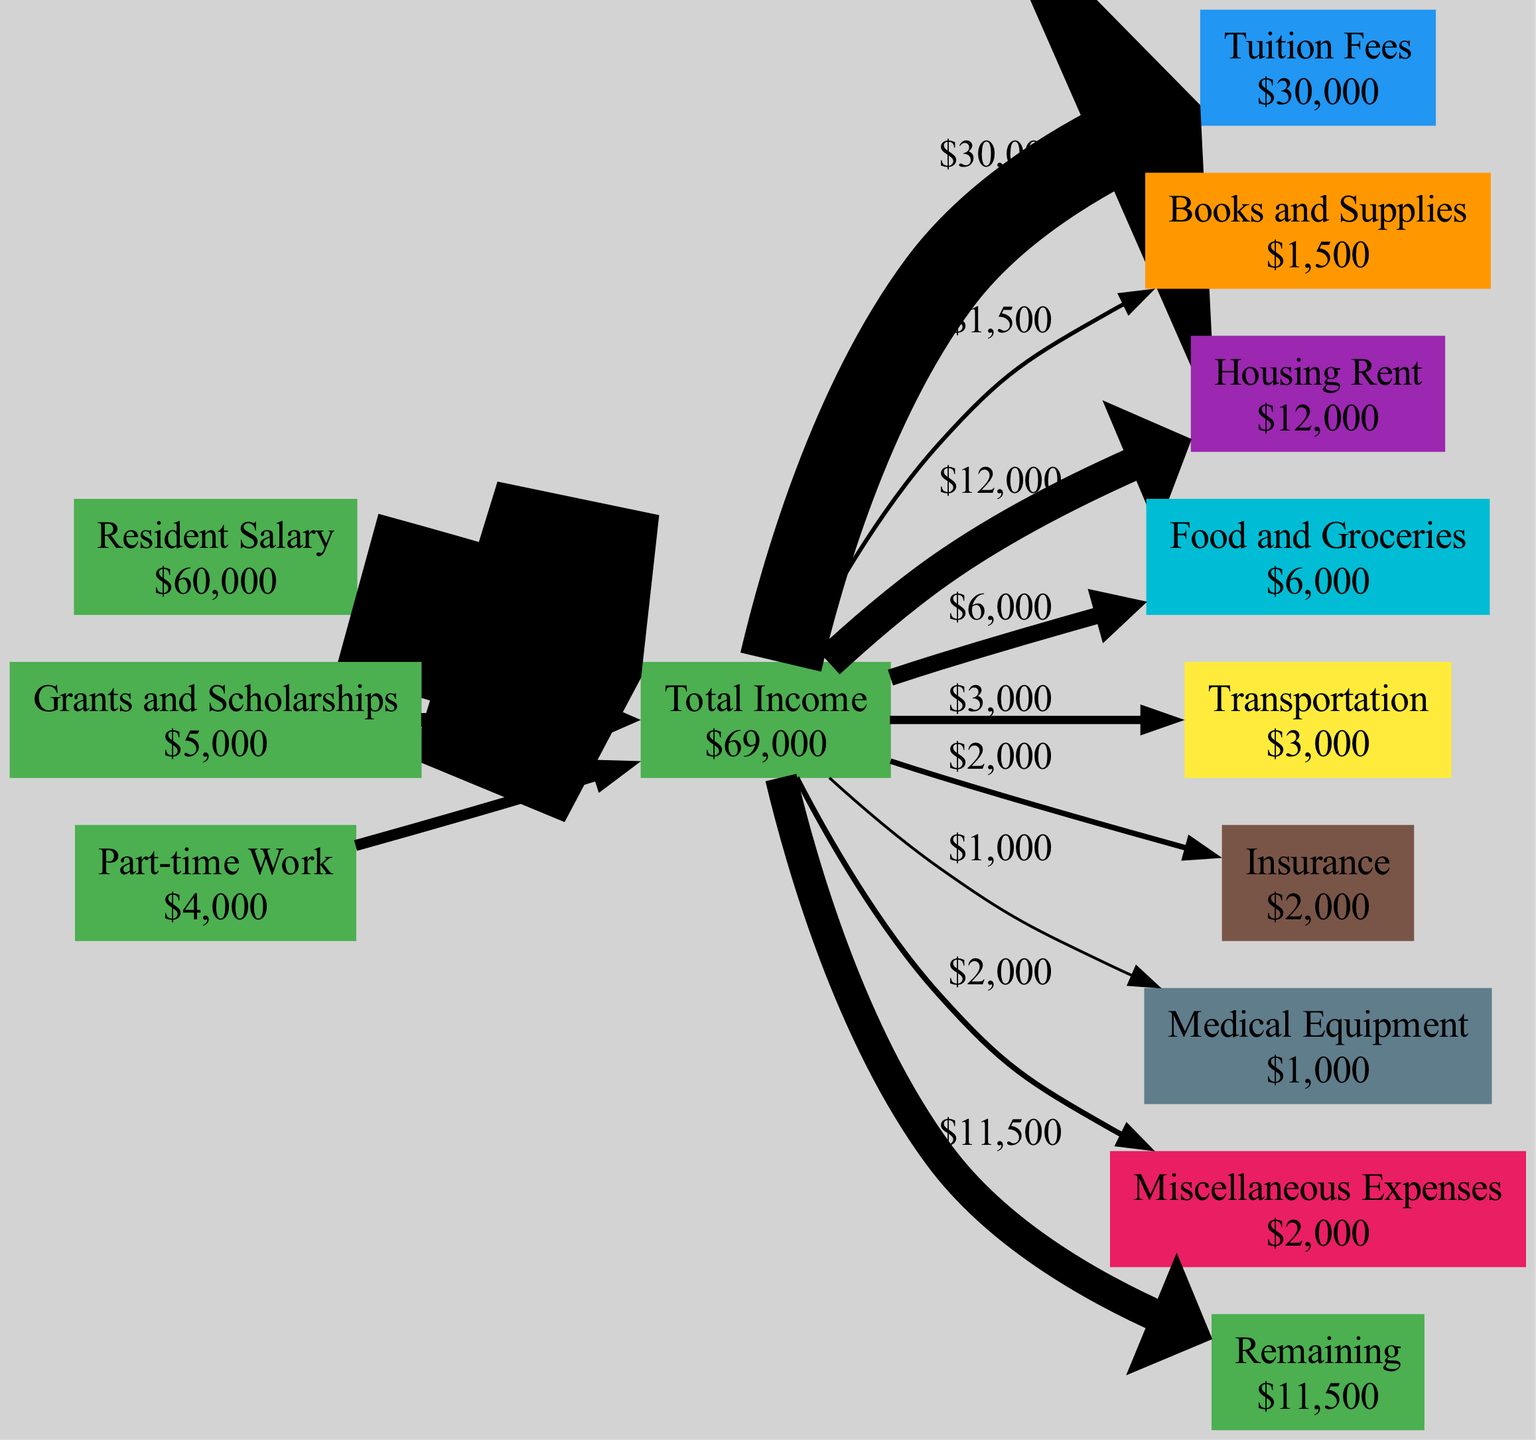What is the total amount of tuition fees? From the expenses section of the diagram, the node for Tuition Fees shows an amount of $30,000.
Answer: $30,000 What is the total income of the resident? The Total Income node aggregates all income amounts: Resident Salary ($60,000), Grants and Scholarships ($5,000), and Part-time Work ($4,000). Adding these gives $60,000 + $5,000 + $4,000 = $69,000.
Answer: $69,000 Which expense is the largest? By examining each expense amount listed in the diagram, Tuition Fees shows an amount of $30,000, which is greater than any other expense.
Answer: Tuition Fees How much is spent on food and groceries? The node for Food and Groceries explicitly lists an expense amount of $6,000 in the diagram.
Answer: $6,000 What is the remaining balance after all expenses? The diagram shows a remaining amount calculated by subtracting total expenses ($60,000) from total income ($69,000). The difference is $69,000 - $60,000 = $9,000.
Answer: $9,000 How many different types of expenses are represented? The diagram indicates eight expense nodes: Tuition Fees, Books and Supplies, Housing Rent, Food and Groceries, Transportation, Insurance, Medical Equipment, and Miscellaneous Expenses, totaling eight distinct types.
Answer: 8 What is the percentage of expenses from housing rent compared to total income? Housing Rent is $12,000. To find the percentage, divide $12,000 by total income of $69,000 and multiply by 100: ($12,000 / $69,000) * 100 ≈ 17.39%.
Answer: Approximately 17.39% What does the red color represent in the diagram? In the diagram, the color red indicates expense nodes, representing the various expenditures the resident incurs.
Answer: Expenses Is the resident in a deficit based on the diagram? The remaining balance is calculated as $9,000 (positive), indicating the resident is not in a deficit; instead, they have a surplus.
Answer: No 